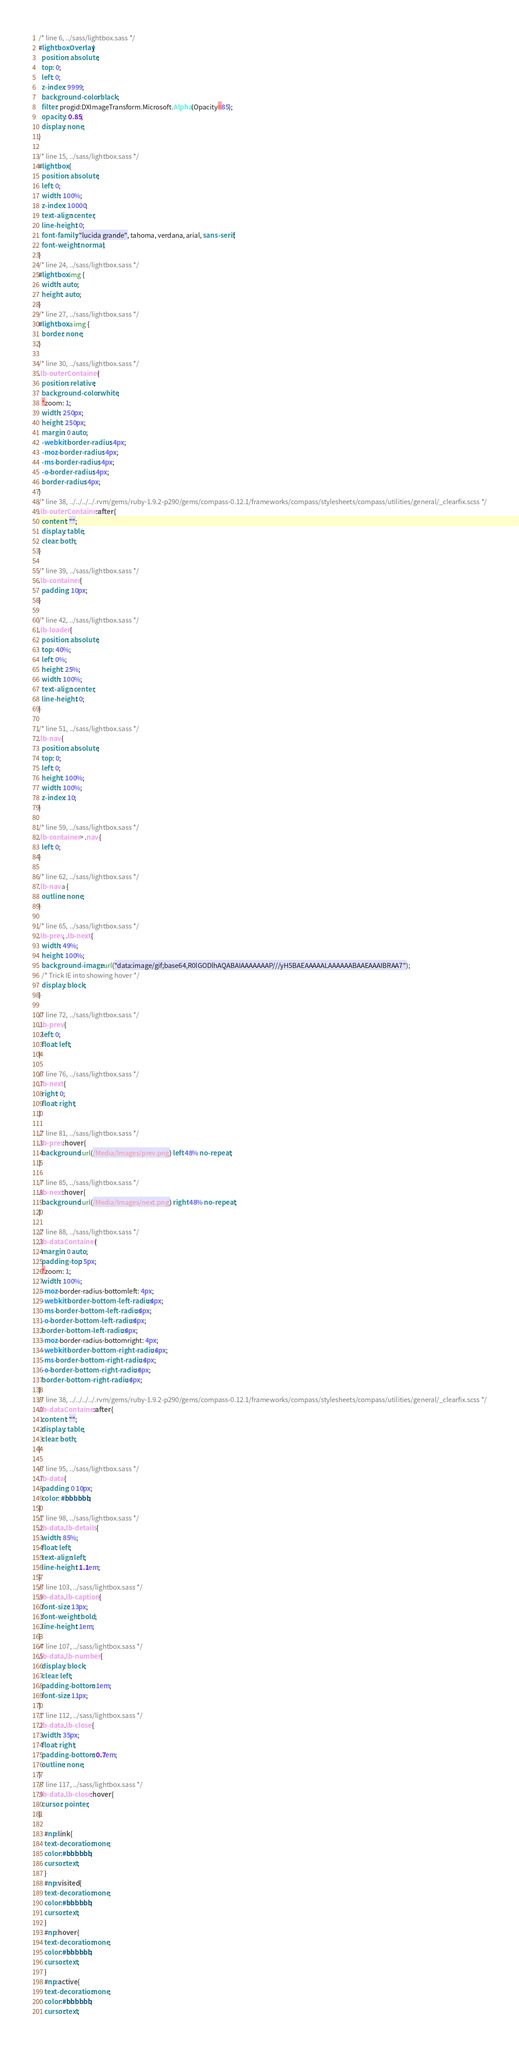<code> <loc_0><loc_0><loc_500><loc_500><_CSS_>/* line 6, ../sass/lightbox.sass */
#lightboxOverlay {
  position: absolute;
  top: 0;
  left: 0;
  z-index: 9999;
  background-color: black;
  filter: progid:DXImageTransform.Microsoft.Alpha(Opacity=85);
  opacity: 0.85;
  display: none;
}

/* line 15, ../sass/lightbox.sass */
#lightbox {
  position: absolute;
  left: 0;
  width: 100%;
  z-index: 10000;
  text-align: center;
  line-height: 0;
  font-family: "lucida grande", tahoma, verdana, arial, sans-serif;
  font-weight: normal;
}
/* line 24, ../sass/lightbox.sass */
#lightbox img {
  width: auto;
  height: auto;
}
/* line 27, ../sass/lightbox.sass */
#lightbox a img {
  border: none;
}

/* line 30, ../sass/lightbox.sass */
.lb-outerContainer {
  position: relative;
  background-color: white;
  *zoom: 1;
  width: 250px;
  height: 250px;
  margin: 0 auto;
  -webkit-border-radius: 4px;
  -moz-border-radius: 4px;
  -ms-border-radius: 4px;
  -o-border-radius: 4px;
  border-radius: 4px;
}
/* line 38, ../../../../.rvm/gems/ruby-1.9.2-p290/gems/compass-0.12.1/frameworks/compass/stylesheets/compass/utilities/general/_clearfix.scss */
.lb-outerContainer:after {
  content: "";
  display: table;
  clear: both;
}

/* line 39, ../sass/lightbox.sass */
.lb-container {
  padding: 10px;
}

/* line 42, ../sass/lightbox.sass */
.lb-loader {
  position: absolute;
  top: 40%;
  left: 0%;
  height: 25%;
  width: 100%;
  text-align: center;
  line-height: 0;
}

/* line 51, ../sass/lightbox.sass */
.lb-nav {
  position: absolute;
  top: 0;
  left: 0;
  height: 100%;
  width: 100%;
  z-index: 10;
}

/* line 59, ../sass/lightbox.sass */
.lb-container > .nav {
  left: 0;
}

/* line 62, ../sass/lightbox.sass */
.lb-nav a {
  outline: none;
}

/* line 65, ../sass/lightbox.sass */
.lb-prev, .lb-next {
  width: 49%;
  height: 100%;
  background-image: url("data:image/gif;base64,R0lGODlhAQABAIAAAAAAAP///yH5BAEAAAAALAAAAAABAAEAAAIBRAA7");
  /* Trick IE into showing hover */
  display: block;
}

/* line 72, ../sass/lightbox.sass */
.lb-prev {
  left: 0;
  float: left;
}

/* line 76, ../sass/lightbox.sass */
.lb-next {
  right: 0;
  float: right;
}

/* line 81, ../sass/lightbox.sass */
.lb-prev:hover {
  background: url(/Media/Images/prev.png) left 48% no-repeat;
}

/* line 85, ../sass/lightbox.sass */
.lb-next:hover {
  background: url(/Media/Images/next.png) right 48% no-repeat;
}

/* line 88, ../sass/lightbox.sass */
.lb-dataContainer {
  margin: 0 auto;
  padding-top: 5px;
  *zoom: 1;
  width: 100%;
  -moz-border-radius-bottomleft: 4px;
  -webkit-border-bottom-left-radius: 4px;
  -ms-border-bottom-left-radius: 4px;
  -o-border-bottom-left-radius: 4px;
  border-bottom-left-radius: 4px;
  -moz-border-radius-bottomright: 4px;
  -webkit-border-bottom-right-radius: 4px;
  -ms-border-bottom-right-radius: 4px;
  -o-border-bottom-right-radius: 4px;
  border-bottom-right-radius: 4px;
}
/* line 38, ../../../../.rvm/gems/ruby-1.9.2-p290/gems/compass-0.12.1/frameworks/compass/stylesheets/compass/utilities/general/_clearfix.scss */
.lb-dataContainer:after {
  content: "";
  display: table;
  clear: both;
}

/* line 95, ../sass/lightbox.sass */
.lb-data {
  padding: 0 10px;
  color: #bbbbbb;
}
/* line 98, ../sass/lightbox.sass */
.lb-data .lb-details {
  width: 85%;
  float: left;
  text-align: left;
  line-height: 1.1em;
}
/* line 103, ../sass/lightbox.sass */
.lb-data .lb-caption {
  font-size: 13px;
  font-weight: bold;
  line-height: 1em;
}
/* line 107, ../sass/lightbox.sass */
.lb-data .lb-number {
  display: block;
  clear: left;
  padding-bottom: 1em;
  font-size: 11px;
}
/* line 112, ../sass/lightbox.sass */
.lb-data .lb-close {
  width: 35px;
  float: right;
  padding-bottom: 0.7em;
  outline: none;
}
/* line 117, ../sass/lightbox.sass */
.lb-data .lb-close:hover {
  cursor: pointer;
}

    #np:link {
	text-decoration:none;
	color:#bbbbbb;
	cursor:text;
	}
	#np:visited {
	text-decoration:none;
	color:#bbbbbb;
	cursor:text;
	}
	#np:hover {
	text-decoration:none;
	color:#bbbbbb;
	cursor:text;
	}
	#np:active {
	text-decoration:none;
	color:#bbbbbb;
	cursor:text;</code> 